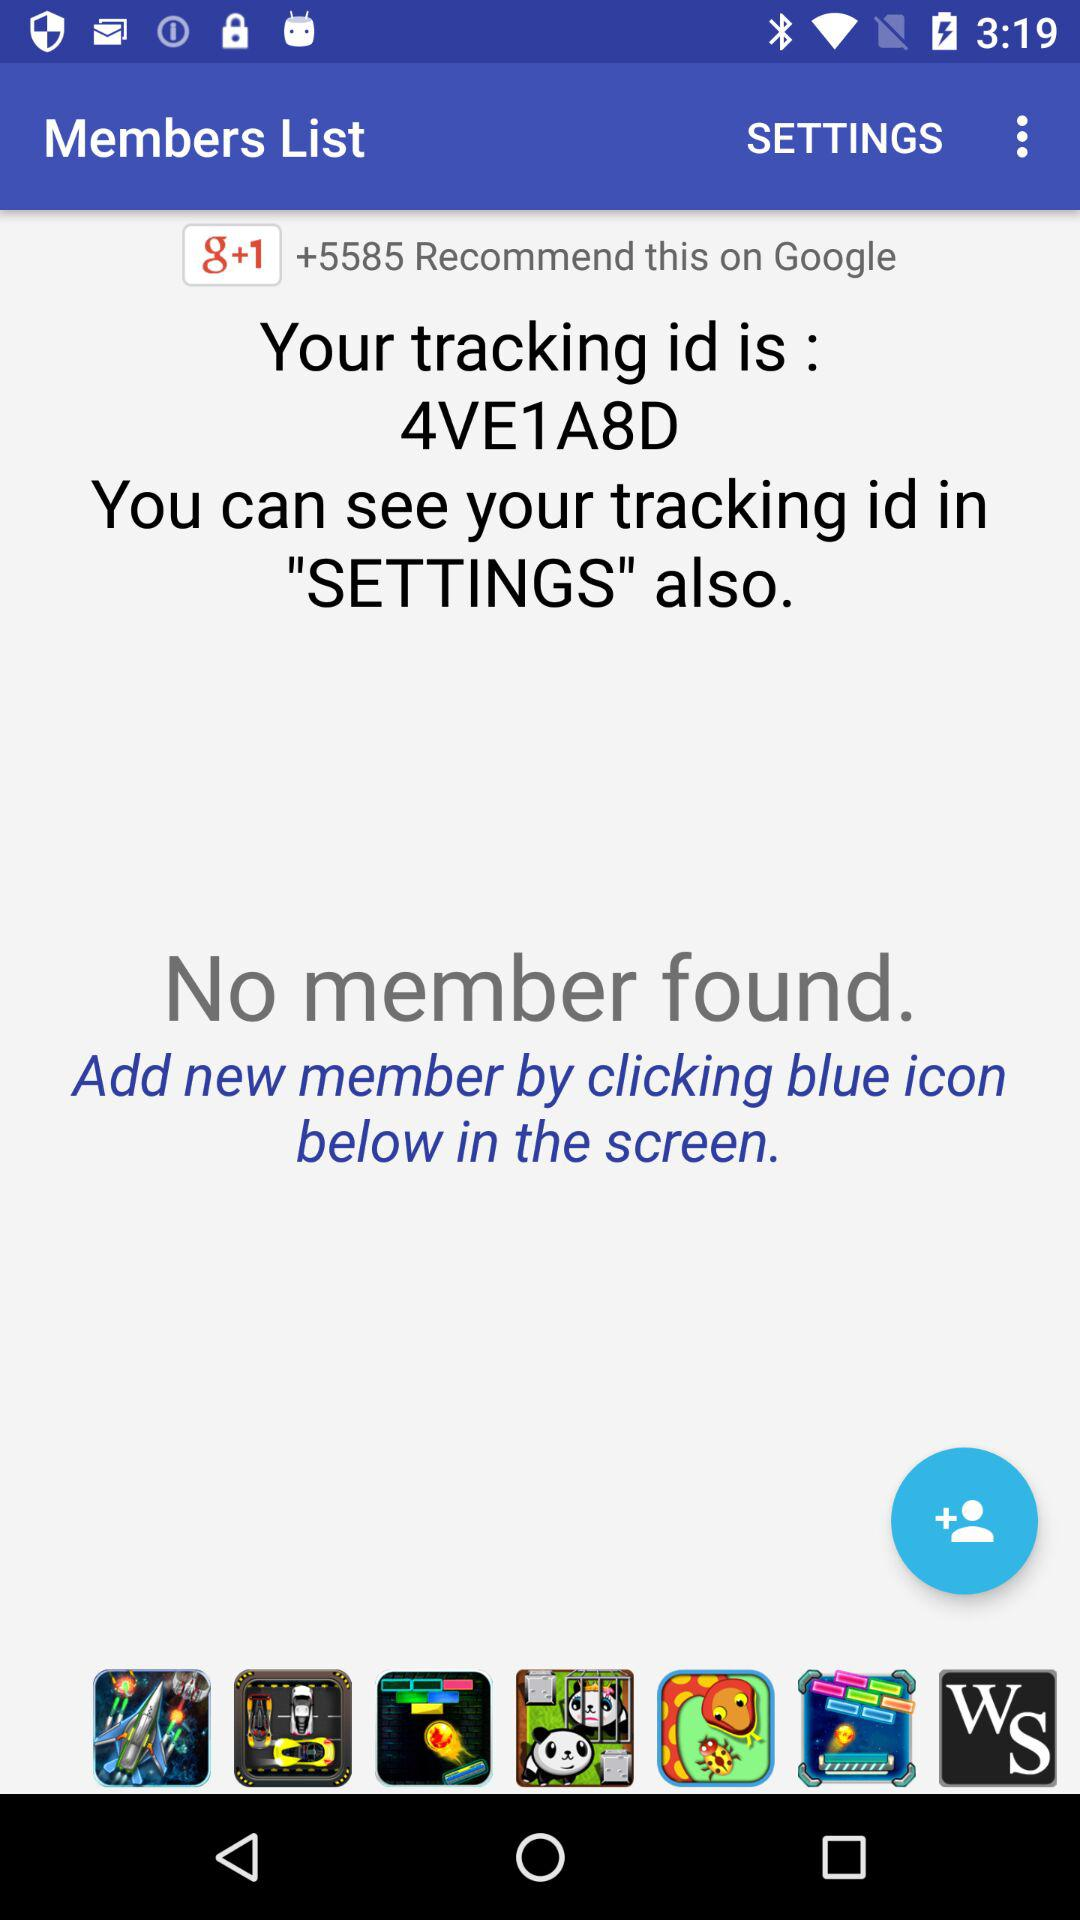How many recommendations are on Google? There are +5585 recommendations. 